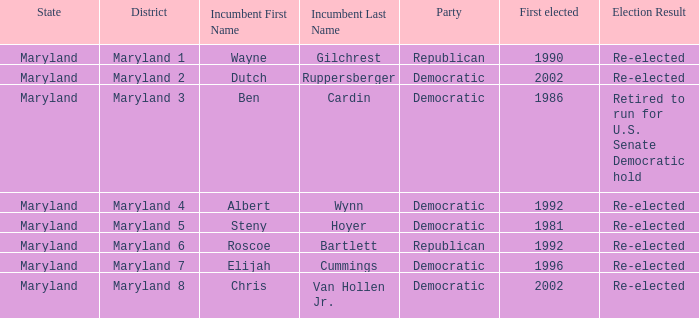What are the results of the incumbent who was first elected in 1996? Re-elected. 